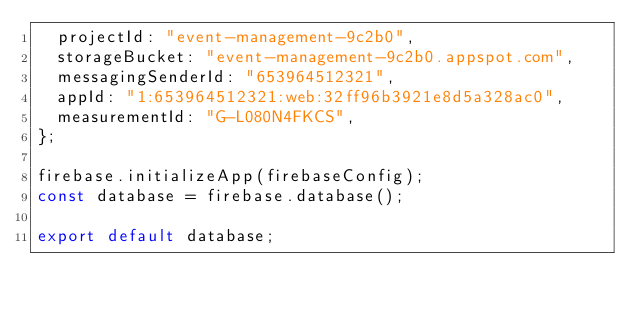<code> <loc_0><loc_0><loc_500><loc_500><_JavaScript_>  projectId: "event-management-9c2b0",
  storageBucket: "event-management-9c2b0.appspot.com",
  messagingSenderId: "653964512321",
  appId: "1:653964512321:web:32ff96b3921e8d5a328ac0",
  measurementId: "G-L080N4FKCS",
};

firebase.initializeApp(firebaseConfig);
const database = firebase.database();

export default database;
</code> 